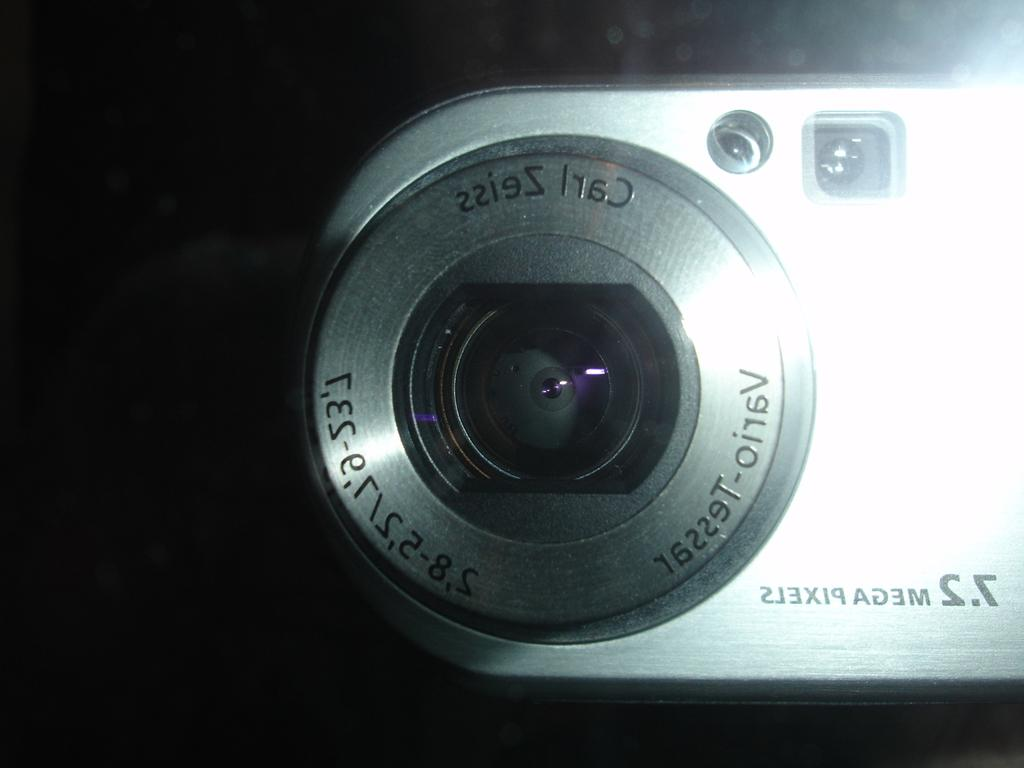What is the main subject of the image? The main subject of the image is a camera. What can be observed about the background of the image? The background of the image is dark. Can you hear the sound of a quarter being dropped in the image? There is no sound present in the image, as it is a static visual representation. Are there any crying individuals visible in the image? There are no individuals, crying or otherwise, visible in the image. 